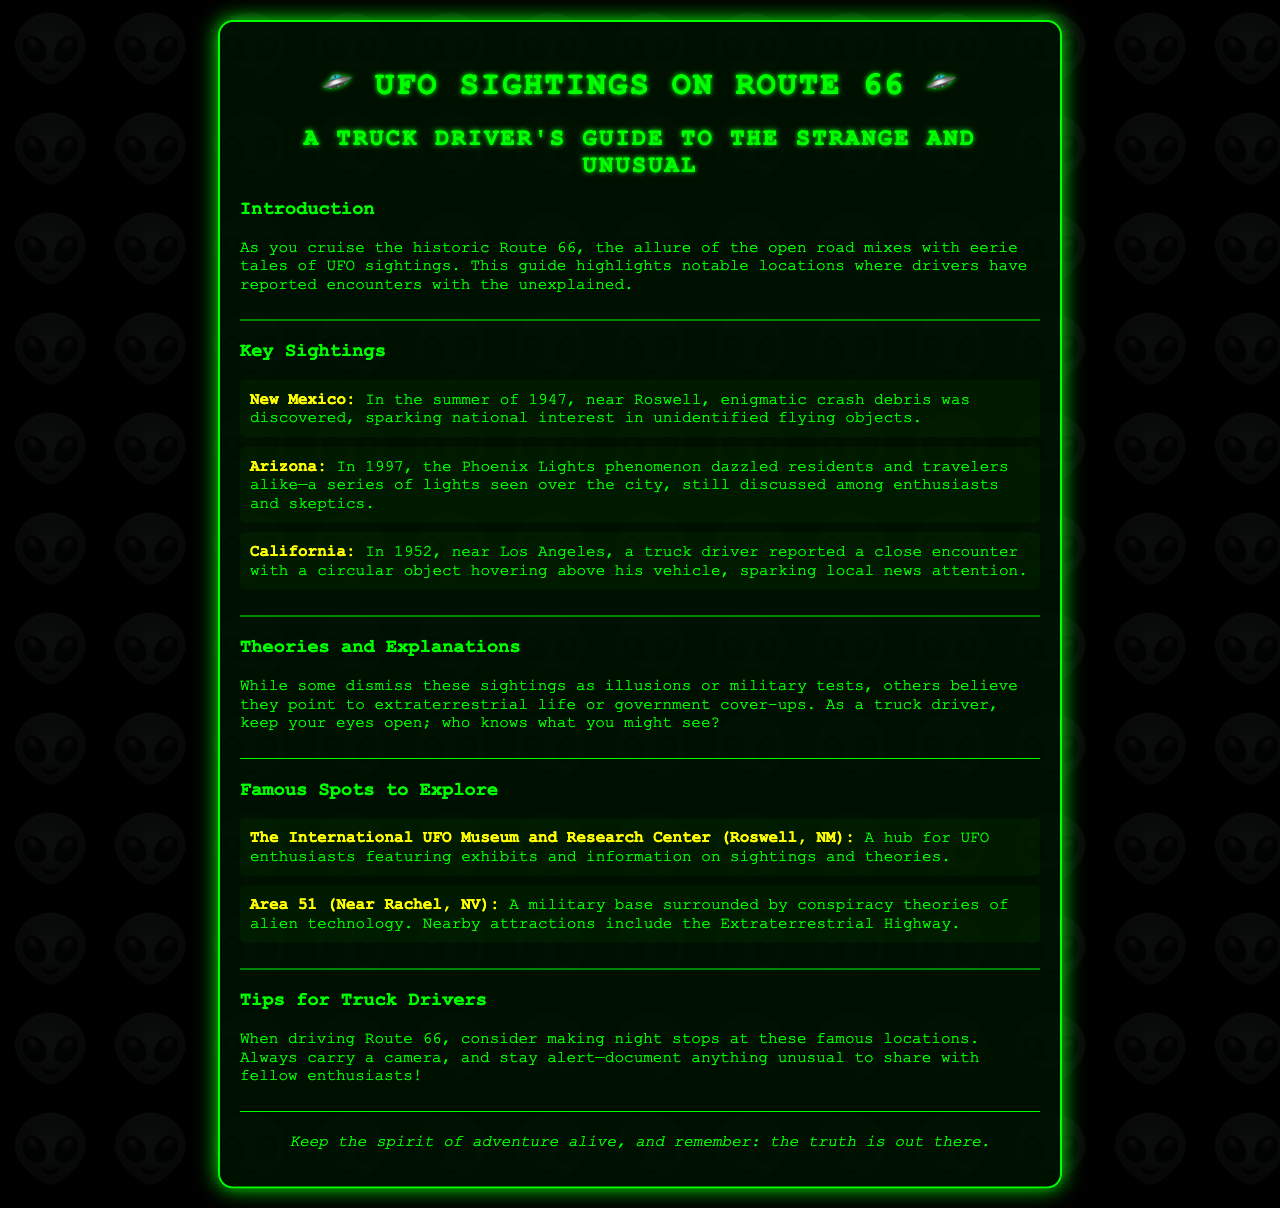What notable event occurred in New Mexico in 1947? The document states that in the summer of 1947, near Roswell, enigmatic crash debris was discovered, sparking national interest.
Answer: Crash debris What was observed in Arizona in 1997? The brochure mentions the Phoenix Lights phenomenon, which was a series of lights seen over the city.
Answer: Phoenix Lights What is the address of a famous UFO museum in Roswell? The document refers to The International UFO Museum and Research Center located in Roswell, NM.
Answer: Roswell, NM What unusual object did a truck driver encounter in California in 1952? The document mentions a circular object hovering above the vehicle during the encounter.
Answer: Circular object What does the brochure suggest truck drivers should always carry? It advises truck drivers to always carry a camera while driving Route 66.
Answer: Camera What are the two potential explanations mentioned for UFO sightings? The document discusses dismissing sightings as illusions or military tests versus beliefs in extraterrestrial life or government cover-ups.
Answer: Illusions or military tests; extraterrestrial life or government cover-ups How is the layout of the brochure structured? It is organized into sections with headings, including Introduction, Key Sightings, Theories and Explanations, Famous Spots, and Tips for Truck Drivers.
Answer: Sections with headings Which highway is referenced in connection with Area 51? The document mentions the Extraterrestrial Highway, which is associated with Area 51.
Answer: Extraterrestrial Highway 